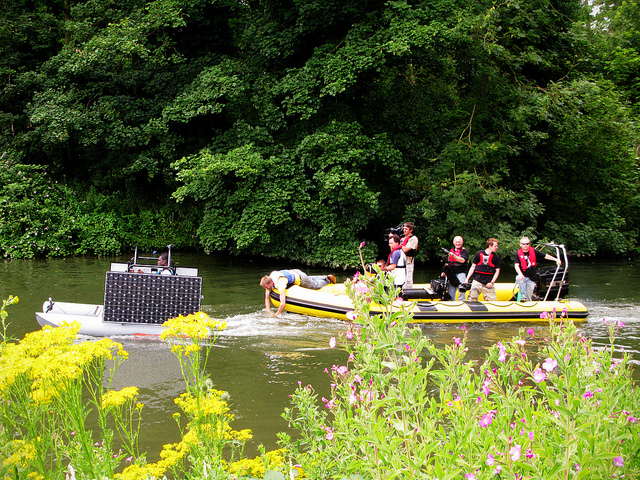What kind of activity might be happening on the river? The people on the raft seem to be involved in some kind of group activity, likely river rafting or participating in a team-building exercise. The presence of audio equipment on the other boat suggests there might be an event or presentation happening nearby. 